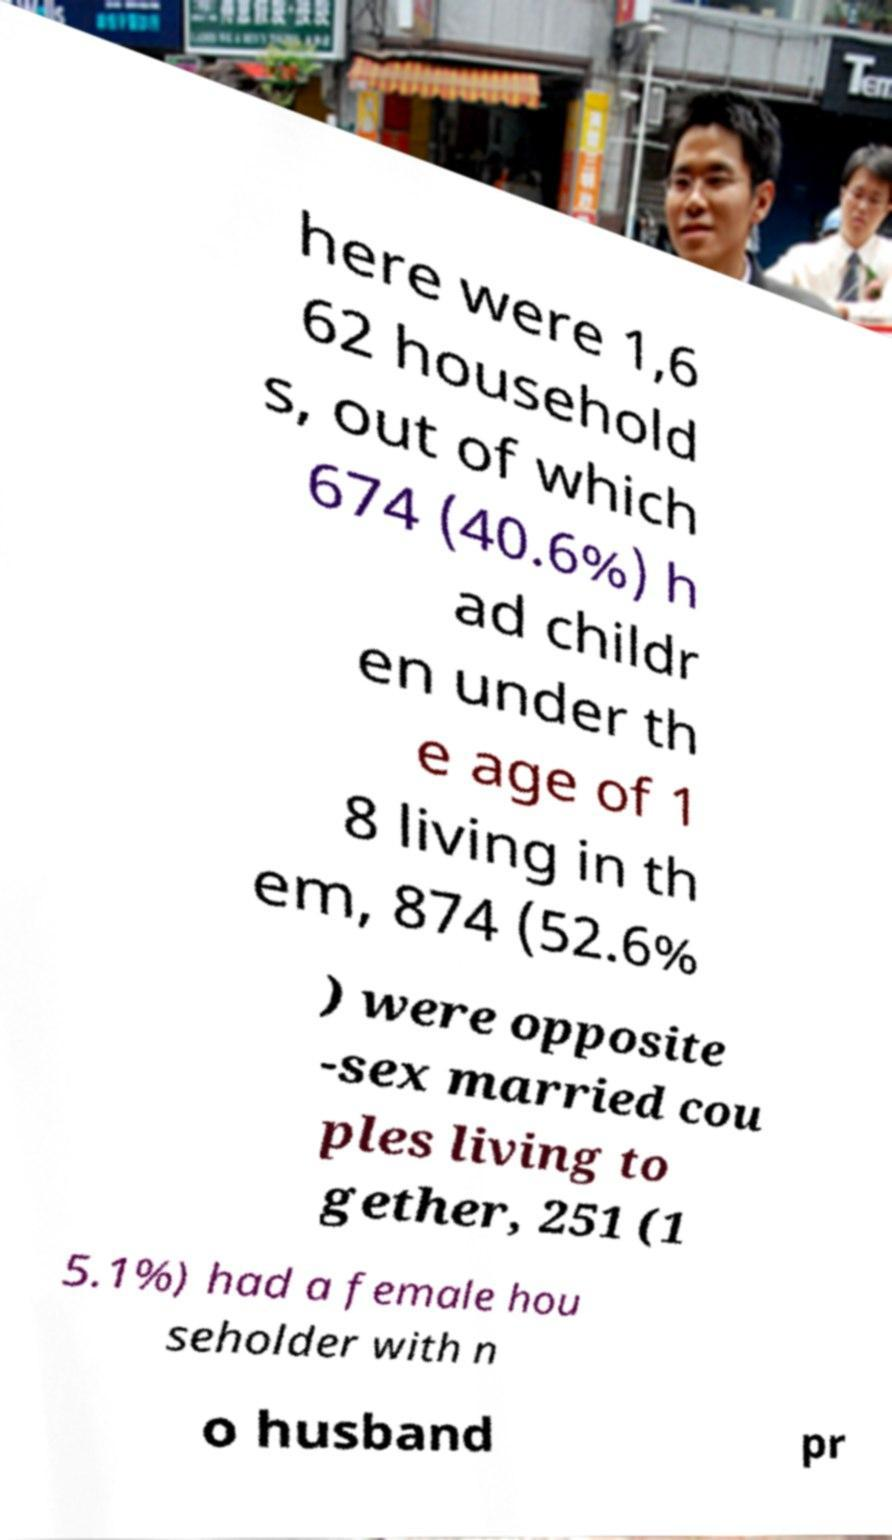Can you accurately transcribe the text from the provided image for me? here were 1,6 62 household s, out of which 674 (40.6%) h ad childr en under th e age of 1 8 living in th em, 874 (52.6% ) were opposite -sex married cou ples living to gether, 251 (1 5.1%) had a female hou seholder with n o husband pr 